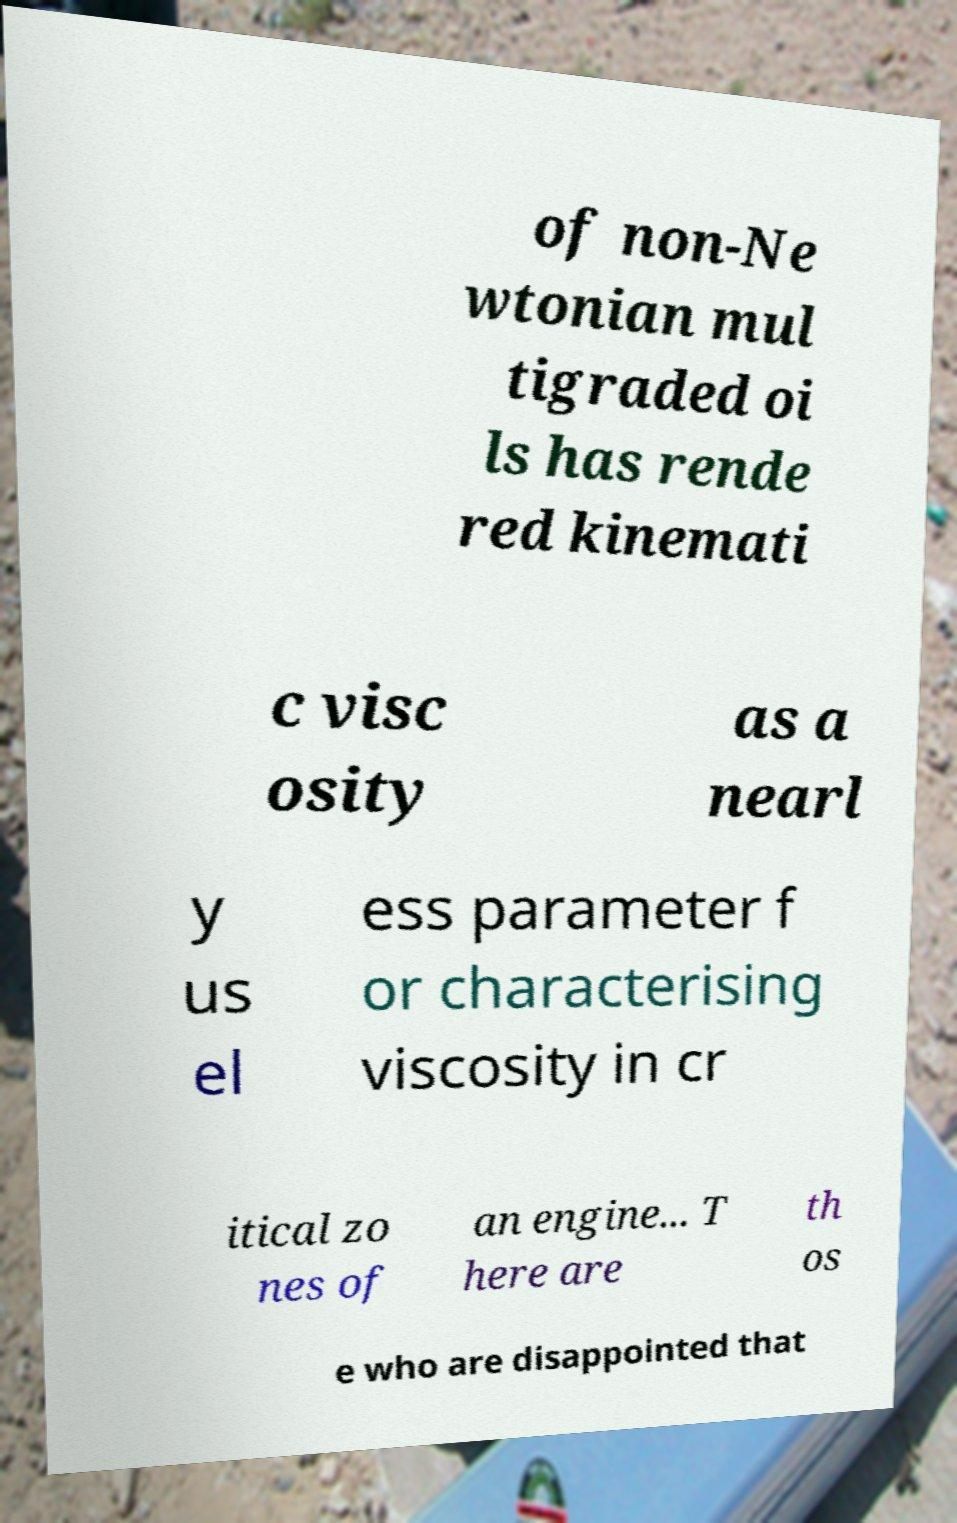Could you assist in decoding the text presented in this image and type it out clearly? of non-Ne wtonian mul tigraded oi ls has rende red kinemati c visc osity as a nearl y us el ess parameter f or characterising viscosity in cr itical zo nes of an engine... T here are th os e who are disappointed that 